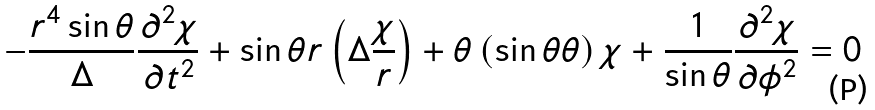<formula> <loc_0><loc_0><loc_500><loc_500>- \frac { r ^ { 4 } \sin \theta } { \Delta } \frac { \partial ^ { 2 } \chi } { \partial t ^ { 2 } } + \sin \theta { r } \left ( \Delta \frac { \chi } { r } \right ) + { \theta } \left ( \sin \theta { \theta } \right ) \chi + \frac { 1 } { \sin \theta } \frac { \partial ^ { 2 } \chi } { \partial \phi ^ { 2 } } = 0</formula> 